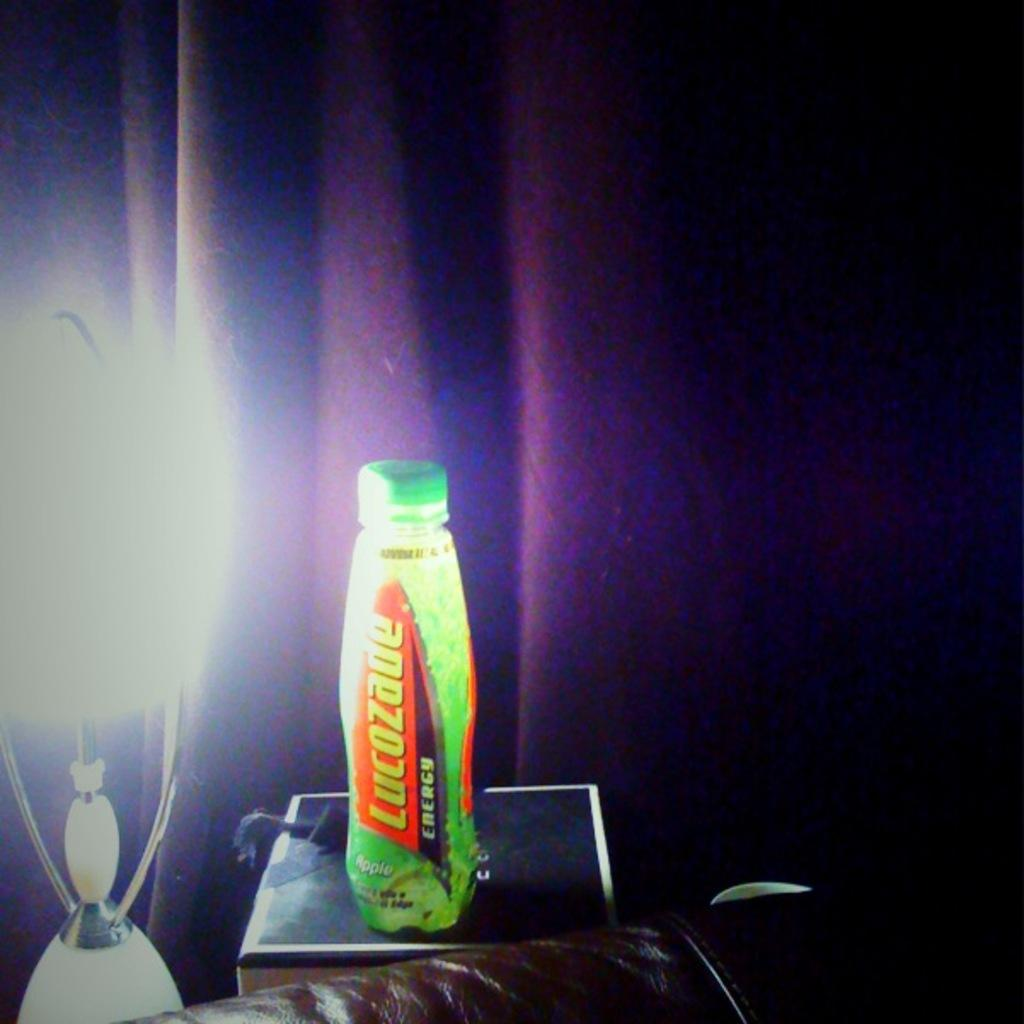<image>
Create a compact narrative representing the image presented. Lucozade Energy Drink with a green background next to a lamp. 